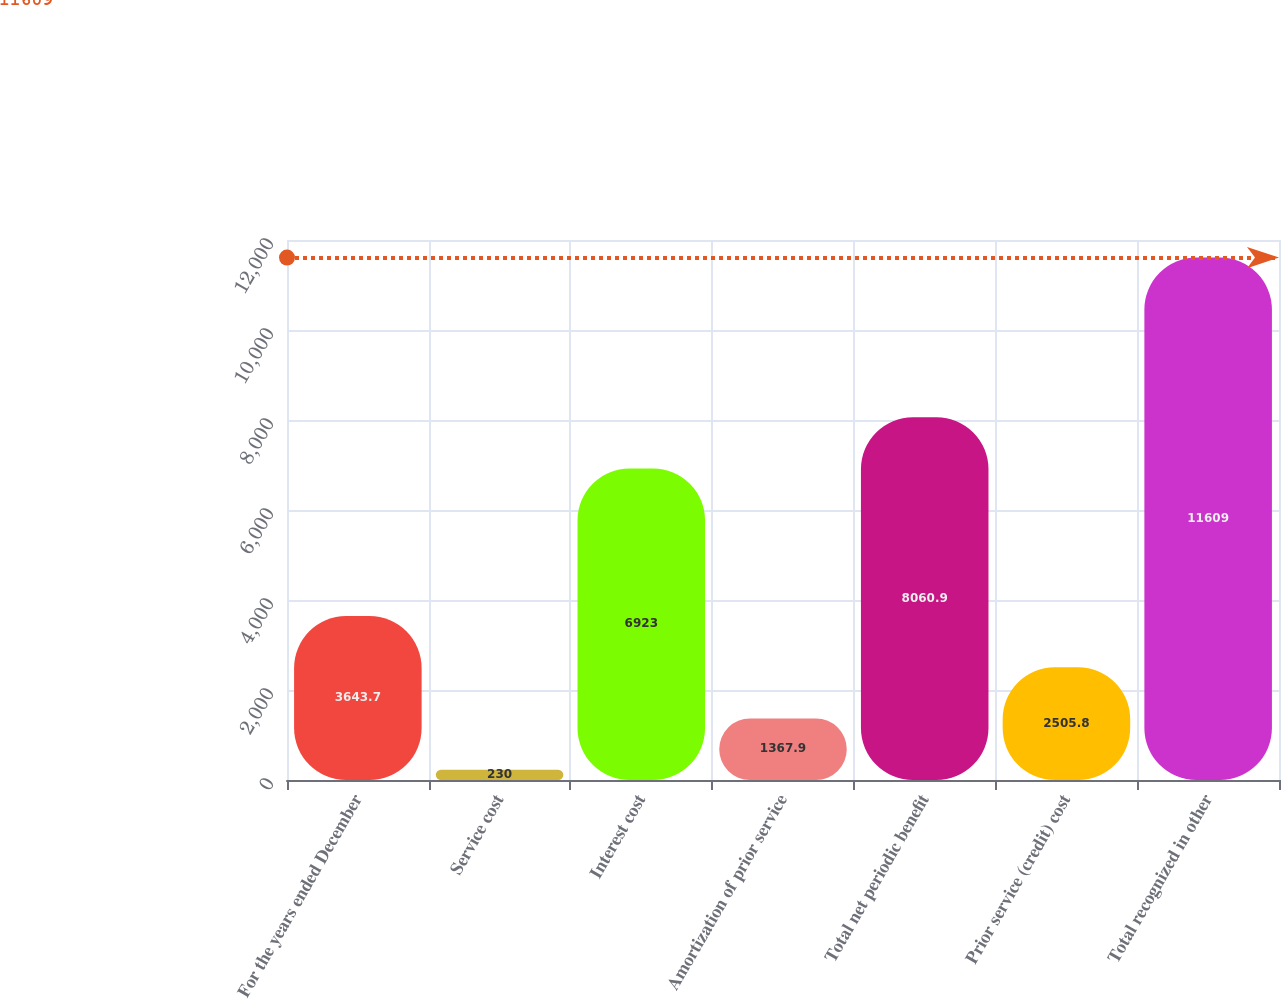Convert chart to OTSL. <chart><loc_0><loc_0><loc_500><loc_500><bar_chart><fcel>For the years ended December<fcel>Service cost<fcel>Interest cost<fcel>Amortization of prior service<fcel>Total net periodic benefit<fcel>Prior service (credit) cost<fcel>Total recognized in other<nl><fcel>3643.7<fcel>230<fcel>6923<fcel>1367.9<fcel>8060.9<fcel>2505.8<fcel>11609<nl></chart> 